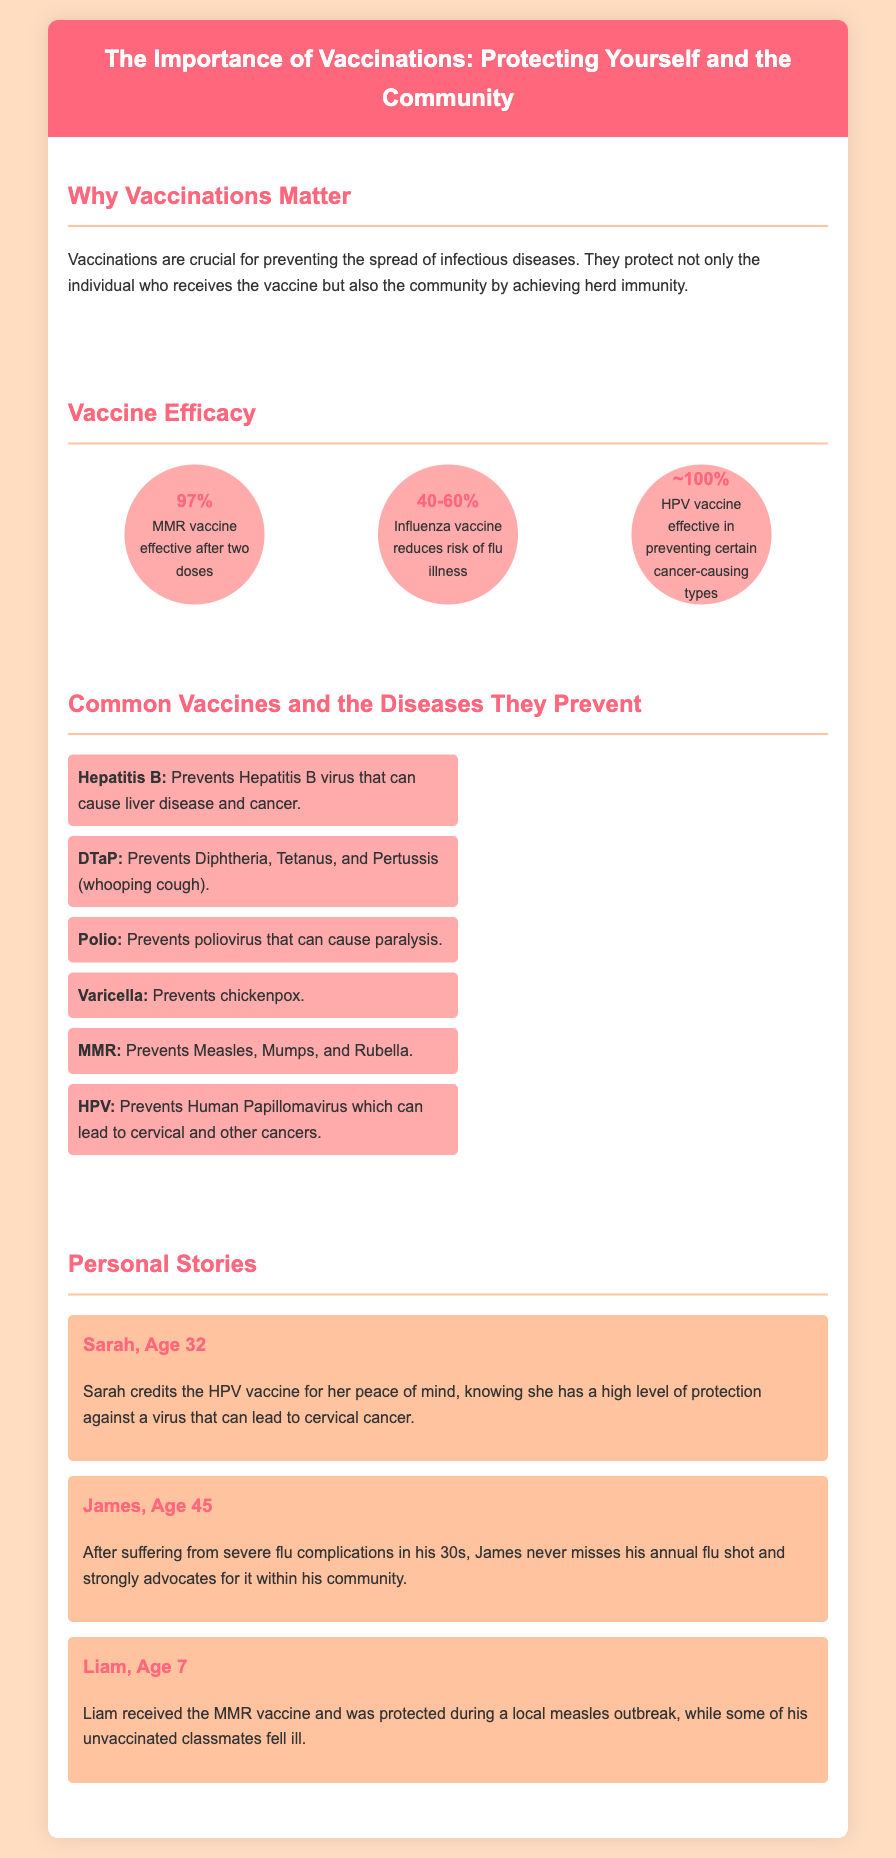What is the effectiveness of the MMR vaccine? The document states that the MMR vaccine is effective after two doses, with an efficacy of 97%.
Answer: 97% Which disease does the DTaP vaccine prevent? The flyer lists that the DTaP vaccine prevents Diphtheria, Tetanus, and Pertussis (whooping cough).
Answer: Diphtheria, Tetanus, and Pertussis What age is Sarah? The personal story mentions that Sarah is age 32.
Answer: 32 What is the effectiveness of the HPV vaccine? The document claims that the HPV vaccine is effective in preventing certain cancer-causing types with an efficacy of approximately 100%.
Answer: ~100% Who suffers from severe flu complications? The personal story describes James, who suffered from severe flu complications in his 30s.
Answer: James How many common vaccines are listed in the flyer? The document includes a list of six common vaccines and the diseases they prevent.
Answer: Six What personal benefit does Liam mention from receiving the MMR vaccine? Liam states that he was protected during a local measles outbreak after receiving the MMR vaccine.
Answer: Protected during a local measles outbreak What color is the header background? The header background color is a shade of pink, specifically #FF677D.
Answer: Pink 